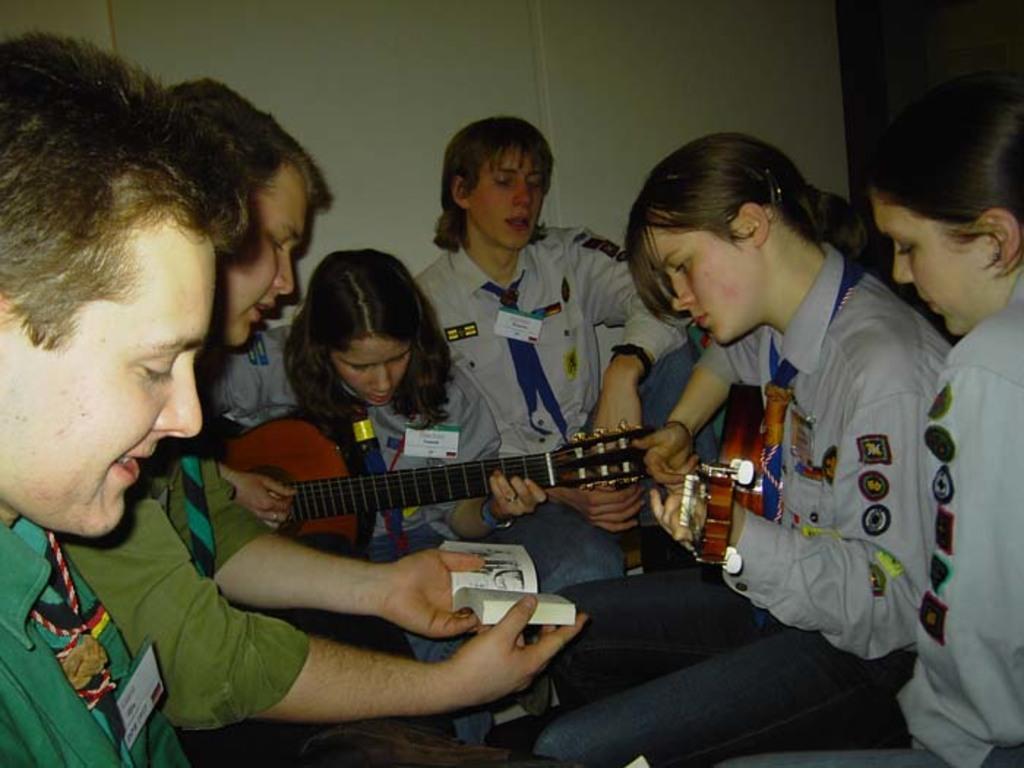Could you give a brief overview of what you see in this image? There is a group of people. They are sitting on a chairs. They are wearing id cards. The middle of the person is holding a guitar. On the left side of the person is holding a book. We can see in background wall. 